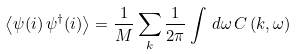<formula> <loc_0><loc_0><loc_500><loc_500>\left \langle \psi ( i ) \, \psi ^ { \dag } ( i ) \right \rangle = \frac { 1 } { M } \sum _ { k } \frac { 1 } { 2 \pi } \int \, d \omega \, C \left ( k , \omega \right )</formula> 